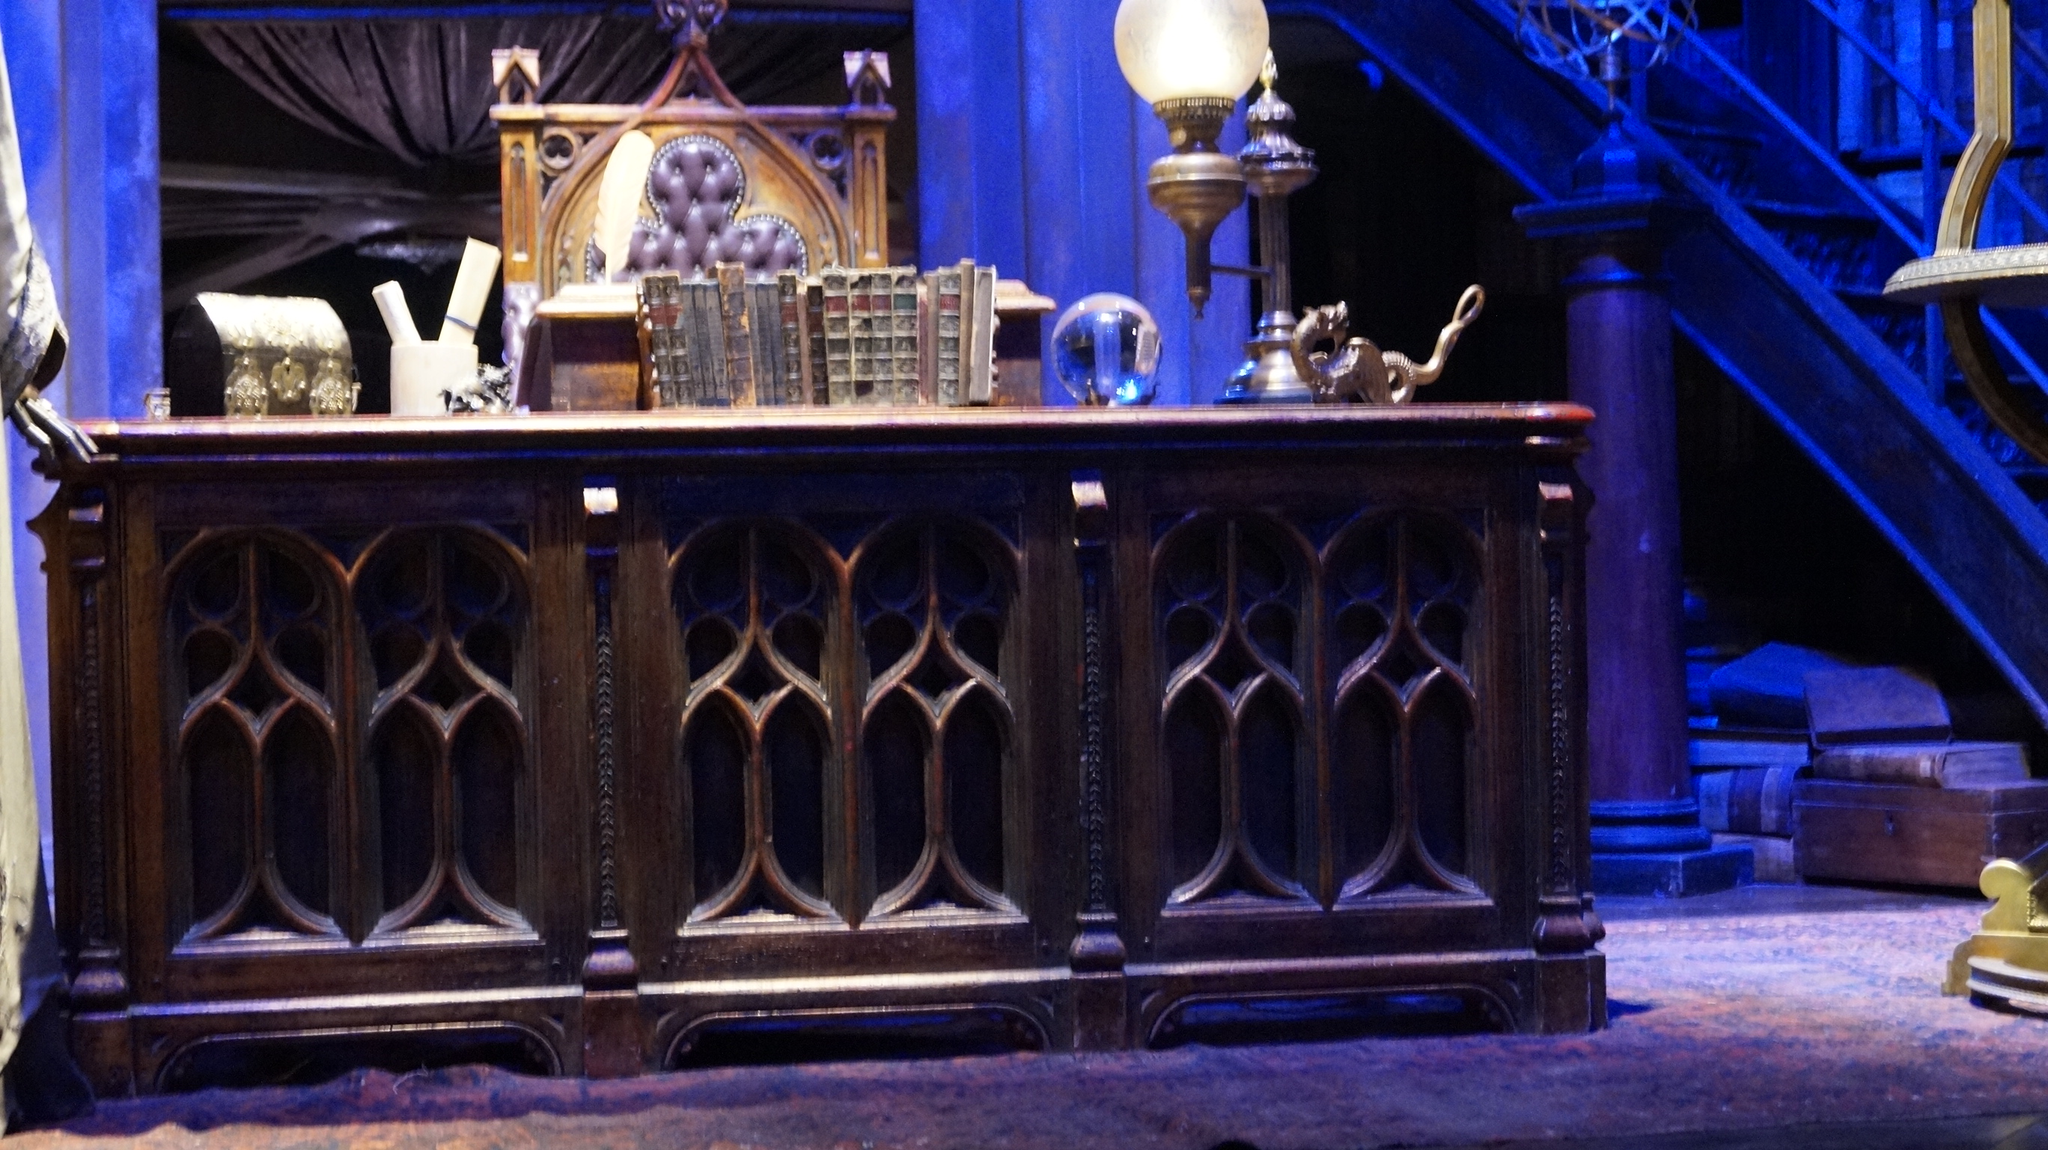In one or two sentences, can you explain what this image depicts? In this picture we can see a table,on this table we can see some objects,here we can see a light and pillar. 